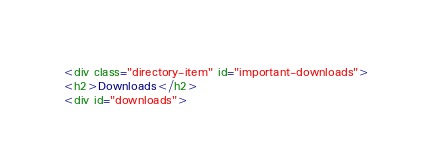<code> <loc_0><loc_0><loc_500><loc_500><_HTML_><div class="directory-item" id="important-downloads">
<h2>Downloads</h2>
<div id="downloads"></code> 